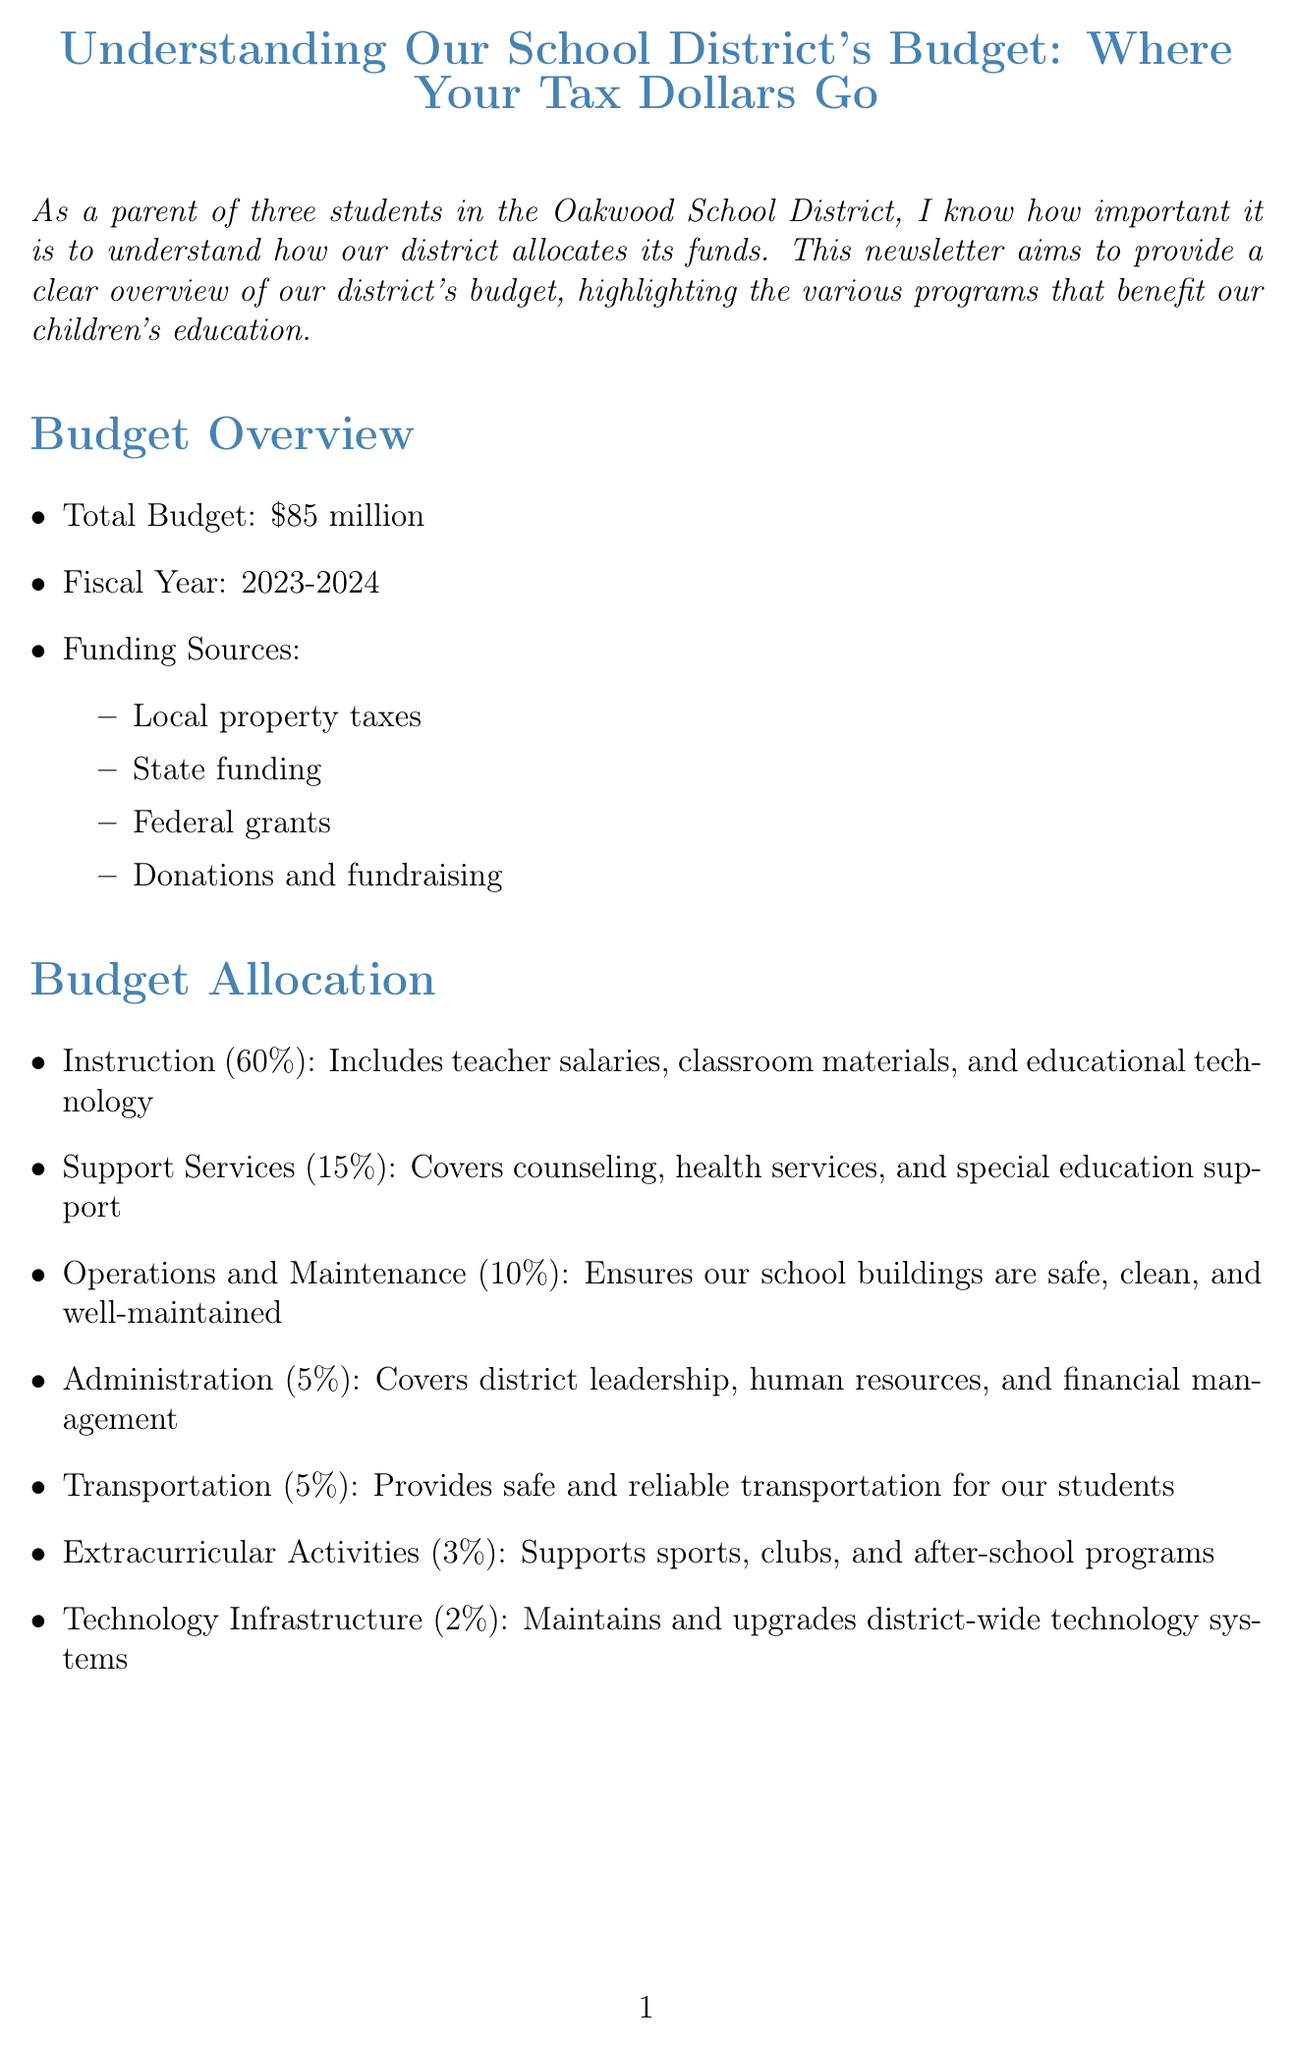What is the total budget for the fiscal year 2023-2024? The total budget stated in the document for the fiscal year 2023-2024 is $85 million.
Answer: $85 million What percentage of the budget is allocated to Instruction? The pie chart indicates that 60 percent of the budget is allocated to Instruction.
Answer: 60 percent How much funding is dedicated to the Special Education Services? The budget for Special Education Services is specified as $8.5 million.
Answer: $8.5 million What are the funding sources listed in the document? The listed funding sources include local property taxes, state funding, federal grants, and donations and fundraising.
Answer: Local property taxes, state funding, federal grants, donations and fundraising Which program focuses on improving reading skills for K-3 students? The program that focuses on improving reading skills for K-3 students is identified as the Early Literacy Program.
Answer: Early Literacy Program What percentage of the budget supports Extracurricular Activities? The budget allocation for Extracurricular Activities is indicated as 3 percent.
Answer: 3 percent What is one way parents can get involved in budget discussions? The document mentions attending school board meetings as one way for parents to get involved.
Answer: Attend school board meetings How many students does the author have? The author states they have three students in their family.
Answer: Three students 